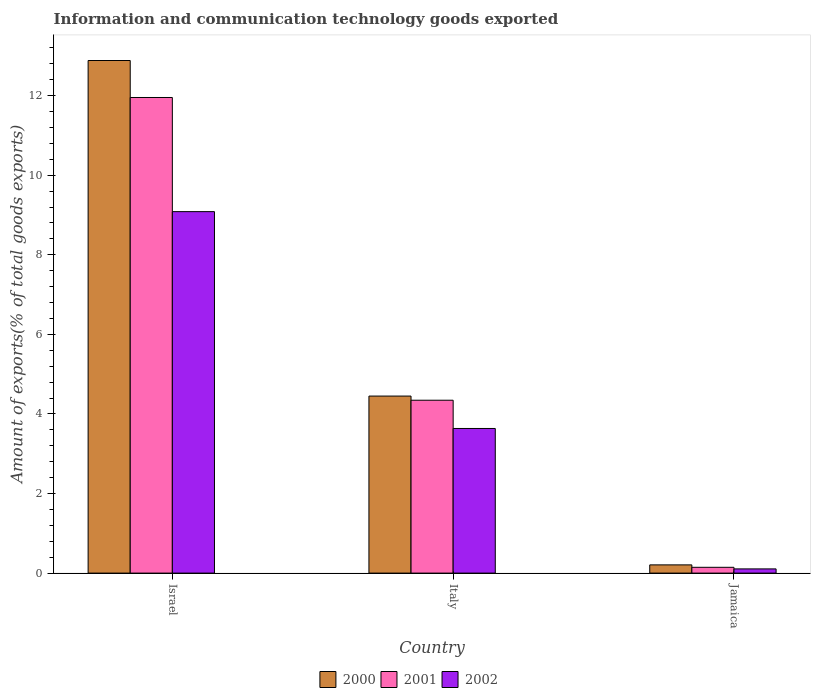How many different coloured bars are there?
Your response must be concise. 3. How many bars are there on the 2nd tick from the left?
Keep it short and to the point. 3. What is the label of the 3rd group of bars from the left?
Offer a very short reply. Jamaica. In how many cases, is the number of bars for a given country not equal to the number of legend labels?
Your answer should be very brief. 0. What is the amount of goods exported in 2002 in Italy?
Provide a succinct answer. 3.63. Across all countries, what is the maximum amount of goods exported in 2000?
Your response must be concise. 12.88. Across all countries, what is the minimum amount of goods exported in 2001?
Provide a short and direct response. 0.15. In which country was the amount of goods exported in 2001 maximum?
Give a very brief answer. Israel. In which country was the amount of goods exported in 2001 minimum?
Provide a short and direct response. Jamaica. What is the total amount of goods exported in 2002 in the graph?
Your response must be concise. 12.82. What is the difference between the amount of goods exported in 2001 in Israel and that in Jamaica?
Your answer should be compact. 11.81. What is the difference between the amount of goods exported in 2001 in Italy and the amount of goods exported in 2002 in Israel?
Give a very brief answer. -4.74. What is the average amount of goods exported in 2000 per country?
Offer a terse response. 5.85. What is the difference between the amount of goods exported of/in 2001 and amount of goods exported of/in 2002 in Italy?
Make the answer very short. 0.71. What is the ratio of the amount of goods exported in 2000 in Israel to that in Jamaica?
Provide a succinct answer. 62.42. What is the difference between the highest and the second highest amount of goods exported in 2000?
Give a very brief answer. -12.68. What is the difference between the highest and the lowest amount of goods exported in 2000?
Offer a very short reply. 12.68. In how many countries, is the amount of goods exported in 2002 greater than the average amount of goods exported in 2002 taken over all countries?
Your response must be concise. 1. Is the sum of the amount of goods exported in 2001 in Israel and Italy greater than the maximum amount of goods exported in 2000 across all countries?
Your answer should be compact. Yes. What does the 2nd bar from the left in Israel represents?
Give a very brief answer. 2001. What does the 1st bar from the right in Italy represents?
Ensure brevity in your answer.  2002. Is it the case that in every country, the sum of the amount of goods exported in 2000 and amount of goods exported in 2002 is greater than the amount of goods exported in 2001?
Your answer should be very brief. Yes. How many bars are there?
Your response must be concise. 9. Are all the bars in the graph horizontal?
Provide a succinct answer. No. How many countries are there in the graph?
Offer a very short reply. 3. What is the difference between two consecutive major ticks on the Y-axis?
Your response must be concise. 2. Are the values on the major ticks of Y-axis written in scientific E-notation?
Provide a succinct answer. No. How are the legend labels stacked?
Offer a terse response. Horizontal. What is the title of the graph?
Your answer should be compact. Information and communication technology goods exported. What is the label or title of the X-axis?
Offer a very short reply. Country. What is the label or title of the Y-axis?
Your answer should be very brief. Amount of exports(% of total goods exports). What is the Amount of exports(% of total goods exports) of 2000 in Israel?
Give a very brief answer. 12.88. What is the Amount of exports(% of total goods exports) of 2001 in Israel?
Your answer should be very brief. 11.95. What is the Amount of exports(% of total goods exports) in 2002 in Israel?
Provide a succinct answer. 9.08. What is the Amount of exports(% of total goods exports) of 2000 in Italy?
Offer a terse response. 4.45. What is the Amount of exports(% of total goods exports) in 2001 in Italy?
Make the answer very short. 4.34. What is the Amount of exports(% of total goods exports) in 2002 in Italy?
Ensure brevity in your answer.  3.63. What is the Amount of exports(% of total goods exports) of 2000 in Jamaica?
Your response must be concise. 0.21. What is the Amount of exports(% of total goods exports) of 2001 in Jamaica?
Give a very brief answer. 0.15. What is the Amount of exports(% of total goods exports) in 2002 in Jamaica?
Make the answer very short. 0.11. Across all countries, what is the maximum Amount of exports(% of total goods exports) in 2000?
Offer a terse response. 12.88. Across all countries, what is the maximum Amount of exports(% of total goods exports) in 2001?
Make the answer very short. 11.95. Across all countries, what is the maximum Amount of exports(% of total goods exports) in 2002?
Your answer should be compact. 9.08. Across all countries, what is the minimum Amount of exports(% of total goods exports) in 2000?
Offer a terse response. 0.21. Across all countries, what is the minimum Amount of exports(% of total goods exports) in 2001?
Give a very brief answer. 0.15. Across all countries, what is the minimum Amount of exports(% of total goods exports) in 2002?
Your response must be concise. 0.11. What is the total Amount of exports(% of total goods exports) of 2000 in the graph?
Your response must be concise. 17.54. What is the total Amount of exports(% of total goods exports) in 2001 in the graph?
Your answer should be very brief. 16.44. What is the total Amount of exports(% of total goods exports) in 2002 in the graph?
Give a very brief answer. 12.82. What is the difference between the Amount of exports(% of total goods exports) in 2000 in Israel and that in Italy?
Your answer should be very brief. 8.43. What is the difference between the Amount of exports(% of total goods exports) in 2001 in Israel and that in Italy?
Keep it short and to the point. 7.61. What is the difference between the Amount of exports(% of total goods exports) in 2002 in Israel and that in Italy?
Give a very brief answer. 5.45. What is the difference between the Amount of exports(% of total goods exports) of 2000 in Israel and that in Jamaica?
Give a very brief answer. 12.68. What is the difference between the Amount of exports(% of total goods exports) of 2001 in Israel and that in Jamaica?
Make the answer very short. 11.81. What is the difference between the Amount of exports(% of total goods exports) of 2002 in Israel and that in Jamaica?
Provide a succinct answer. 8.98. What is the difference between the Amount of exports(% of total goods exports) of 2000 in Italy and that in Jamaica?
Make the answer very short. 4.24. What is the difference between the Amount of exports(% of total goods exports) of 2001 in Italy and that in Jamaica?
Keep it short and to the point. 4.2. What is the difference between the Amount of exports(% of total goods exports) in 2002 in Italy and that in Jamaica?
Provide a succinct answer. 3.53. What is the difference between the Amount of exports(% of total goods exports) of 2000 in Israel and the Amount of exports(% of total goods exports) of 2001 in Italy?
Give a very brief answer. 8.54. What is the difference between the Amount of exports(% of total goods exports) of 2000 in Israel and the Amount of exports(% of total goods exports) of 2002 in Italy?
Give a very brief answer. 9.25. What is the difference between the Amount of exports(% of total goods exports) of 2001 in Israel and the Amount of exports(% of total goods exports) of 2002 in Italy?
Ensure brevity in your answer.  8.32. What is the difference between the Amount of exports(% of total goods exports) of 2000 in Israel and the Amount of exports(% of total goods exports) of 2001 in Jamaica?
Ensure brevity in your answer.  12.74. What is the difference between the Amount of exports(% of total goods exports) of 2000 in Israel and the Amount of exports(% of total goods exports) of 2002 in Jamaica?
Ensure brevity in your answer.  12.78. What is the difference between the Amount of exports(% of total goods exports) in 2001 in Israel and the Amount of exports(% of total goods exports) in 2002 in Jamaica?
Give a very brief answer. 11.85. What is the difference between the Amount of exports(% of total goods exports) of 2000 in Italy and the Amount of exports(% of total goods exports) of 2001 in Jamaica?
Make the answer very short. 4.3. What is the difference between the Amount of exports(% of total goods exports) of 2000 in Italy and the Amount of exports(% of total goods exports) of 2002 in Jamaica?
Make the answer very short. 4.34. What is the difference between the Amount of exports(% of total goods exports) in 2001 in Italy and the Amount of exports(% of total goods exports) in 2002 in Jamaica?
Make the answer very short. 4.24. What is the average Amount of exports(% of total goods exports) of 2000 per country?
Provide a short and direct response. 5.85. What is the average Amount of exports(% of total goods exports) in 2001 per country?
Provide a succinct answer. 5.48. What is the average Amount of exports(% of total goods exports) of 2002 per country?
Your answer should be very brief. 4.27. What is the difference between the Amount of exports(% of total goods exports) of 2000 and Amount of exports(% of total goods exports) of 2001 in Israel?
Ensure brevity in your answer.  0.93. What is the difference between the Amount of exports(% of total goods exports) in 2000 and Amount of exports(% of total goods exports) in 2002 in Israel?
Give a very brief answer. 3.8. What is the difference between the Amount of exports(% of total goods exports) in 2001 and Amount of exports(% of total goods exports) in 2002 in Israel?
Offer a very short reply. 2.87. What is the difference between the Amount of exports(% of total goods exports) of 2000 and Amount of exports(% of total goods exports) of 2001 in Italy?
Make the answer very short. 0.1. What is the difference between the Amount of exports(% of total goods exports) in 2000 and Amount of exports(% of total goods exports) in 2002 in Italy?
Give a very brief answer. 0.81. What is the difference between the Amount of exports(% of total goods exports) in 2001 and Amount of exports(% of total goods exports) in 2002 in Italy?
Keep it short and to the point. 0.71. What is the difference between the Amount of exports(% of total goods exports) in 2000 and Amount of exports(% of total goods exports) in 2001 in Jamaica?
Ensure brevity in your answer.  0.06. What is the difference between the Amount of exports(% of total goods exports) of 2000 and Amount of exports(% of total goods exports) of 2002 in Jamaica?
Offer a terse response. 0.1. What is the difference between the Amount of exports(% of total goods exports) of 2001 and Amount of exports(% of total goods exports) of 2002 in Jamaica?
Give a very brief answer. 0.04. What is the ratio of the Amount of exports(% of total goods exports) of 2000 in Israel to that in Italy?
Give a very brief answer. 2.9. What is the ratio of the Amount of exports(% of total goods exports) in 2001 in Israel to that in Italy?
Keep it short and to the point. 2.75. What is the ratio of the Amount of exports(% of total goods exports) in 2002 in Israel to that in Italy?
Give a very brief answer. 2.5. What is the ratio of the Amount of exports(% of total goods exports) in 2000 in Israel to that in Jamaica?
Offer a terse response. 62.42. What is the ratio of the Amount of exports(% of total goods exports) in 2001 in Israel to that in Jamaica?
Your answer should be very brief. 82.1. What is the ratio of the Amount of exports(% of total goods exports) of 2002 in Israel to that in Jamaica?
Your answer should be compact. 86.18. What is the ratio of the Amount of exports(% of total goods exports) of 2000 in Italy to that in Jamaica?
Offer a very short reply. 21.56. What is the ratio of the Amount of exports(% of total goods exports) of 2001 in Italy to that in Jamaica?
Offer a terse response. 29.84. What is the ratio of the Amount of exports(% of total goods exports) of 2002 in Italy to that in Jamaica?
Keep it short and to the point. 34.48. What is the difference between the highest and the second highest Amount of exports(% of total goods exports) of 2000?
Make the answer very short. 8.43. What is the difference between the highest and the second highest Amount of exports(% of total goods exports) in 2001?
Your answer should be very brief. 7.61. What is the difference between the highest and the second highest Amount of exports(% of total goods exports) in 2002?
Provide a short and direct response. 5.45. What is the difference between the highest and the lowest Amount of exports(% of total goods exports) of 2000?
Your answer should be very brief. 12.68. What is the difference between the highest and the lowest Amount of exports(% of total goods exports) in 2001?
Offer a very short reply. 11.81. What is the difference between the highest and the lowest Amount of exports(% of total goods exports) in 2002?
Your answer should be compact. 8.98. 